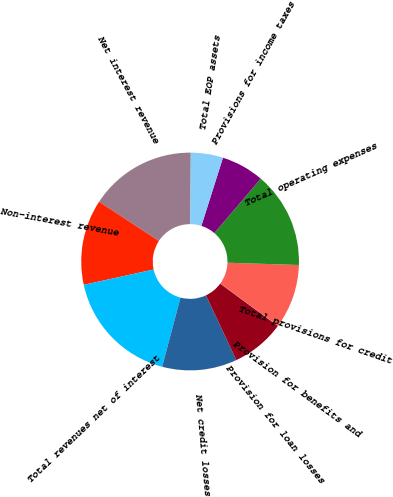Convert chart. <chart><loc_0><loc_0><loc_500><loc_500><pie_chart><fcel>Net interest revenue<fcel>Non-interest revenue<fcel>Total revenues net of interest<fcel>Net credit losses<fcel>Provision for loan losses<fcel>Provision for benefits and<fcel>Total provisions for credit<fcel>Total operating expenses<fcel>Provisions for income taxes<fcel>Total EOP assets<nl><fcel>15.85%<fcel>12.69%<fcel>17.43%<fcel>11.11%<fcel>7.94%<fcel>0.04%<fcel>9.53%<fcel>14.27%<fcel>6.36%<fcel>4.78%<nl></chart> 